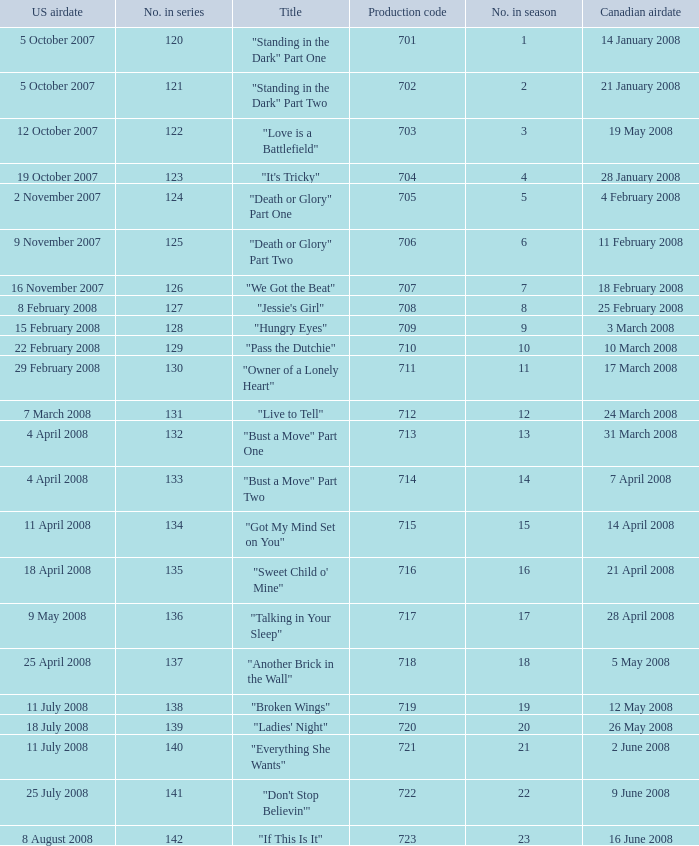For the episode(s) aired in the U.S. on 4 april 2008, what were the names? "Bust a Move" Part One, "Bust a Move" Part Two. 